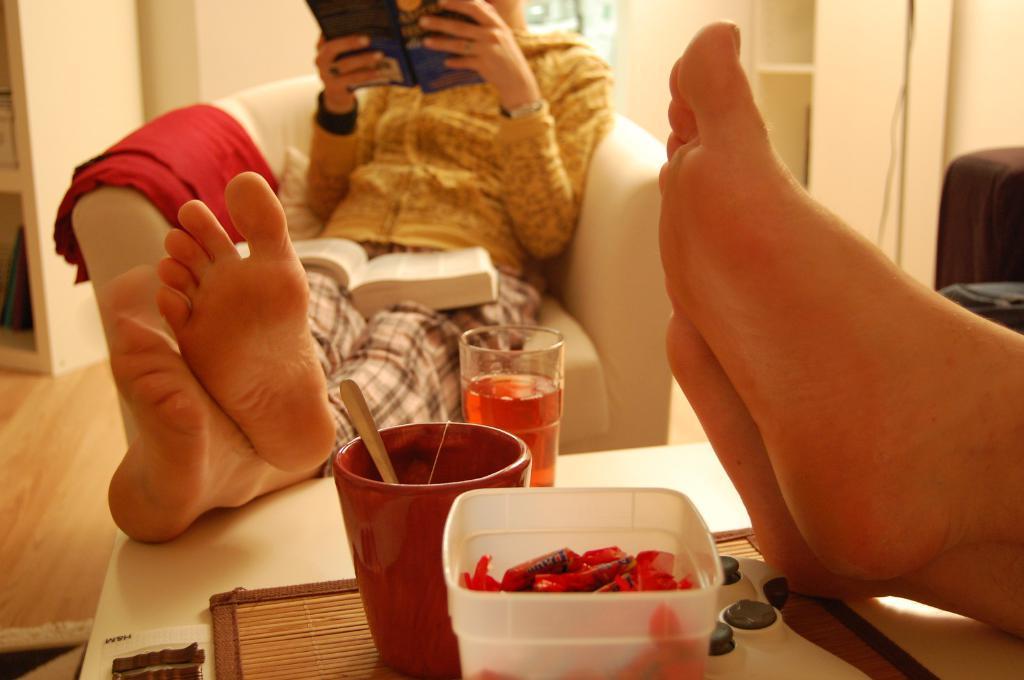How would you summarize this image in a sentence or two? In the picture I can see a person sitting on the sofa and the person is holding a book. There is another book. I can see a red cloth on the sofa. I can see a wooden table on the floor. I can see a glass of juice, a cup and chocolate bowl are kept on the table. I can see the legs of a person on the table on the right side. I can see the wooden drawer on the floor on the top left side. 